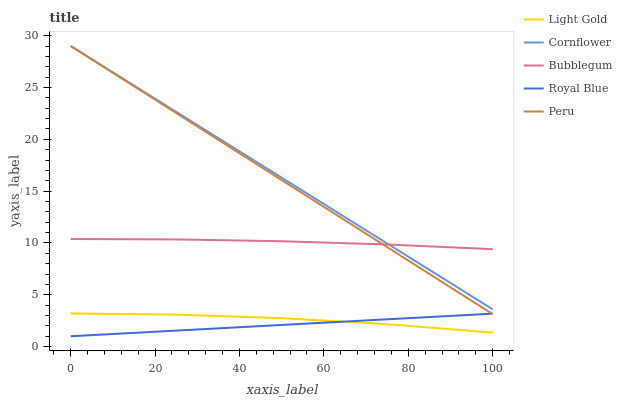Does Royal Blue have the minimum area under the curve?
Answer yes or no. Yes. Does Cornflower have the maximum area under the curve?
Answer yes or no. Yes. Does Light Gold have the minimum area under the curve?
Answer yes or no. No. Does Light Gold have the maximum area under the curve?
Answer yes or no. No. Is Cornflower the smoothest?
Answer yes or no. Yes. Is Light Gold the roughest?
Answer yes or no. Yes. Is Peru the smoothest?
Answer yes or no. No. Is Peru the roughest?
Answer yes or no. No. Does Light Gold have the lowest value?
Answer yes or no. No. Does Peru have the highest value?
Answer yes or no. Yes. Does Light Gold have the highest value?
Answer yes or no. No. Is Light Gold less than Cornflower?
Answer yes or no. Yes. Is Peru greater than Light Gold?
Answer yes or no. Yes. Does Light Gold intersect Royal Blue?
Answer yes or no. Yes. Is Light Gold less than Royal Blue?
Answer yes or no. No. Is Light Gold greater than Royal Blue?
Answer yes or no. No. Does Light Gold intersect Cornflower?
Answer yes or no. No. 